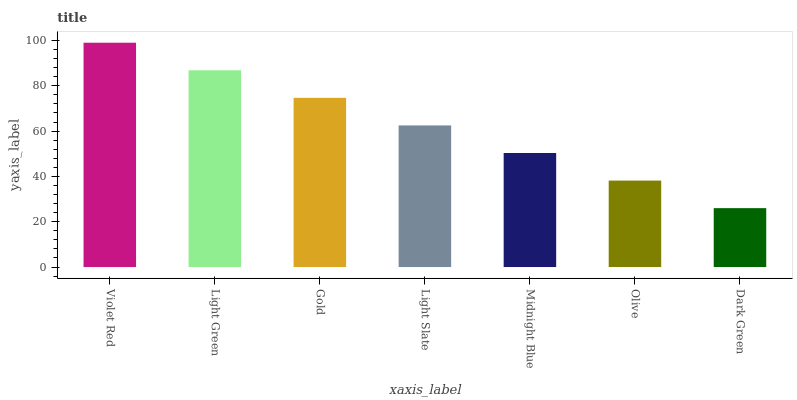Is Dark Green the minimum?
Answer yes or no. Yes. Is Violet Red the maximum?
Answer yes or no. Yes. Is Light Green the minimum?
Answer yes or no. No. Is Light Green the maximum?
Answer yes or no. No. Is Violet Red greater than Light Green?
Answer yes or no. Yes. Is Light Green less than Violet Red?
Answer yes or no. Yes. Is Light Green greater than Violet Red?
Answer yes or no. No. Is Violet Red less than Light Green?
Answer yes or no. No. Is Light Slate the high median?
Answer yes or no. Yes. Is Light Slate the low median?
Answer yes or no. Yes. Is Midnight Blue the high median?
Answer yes or no. No. Is Olive the low median?
Answer yes or no. No. 